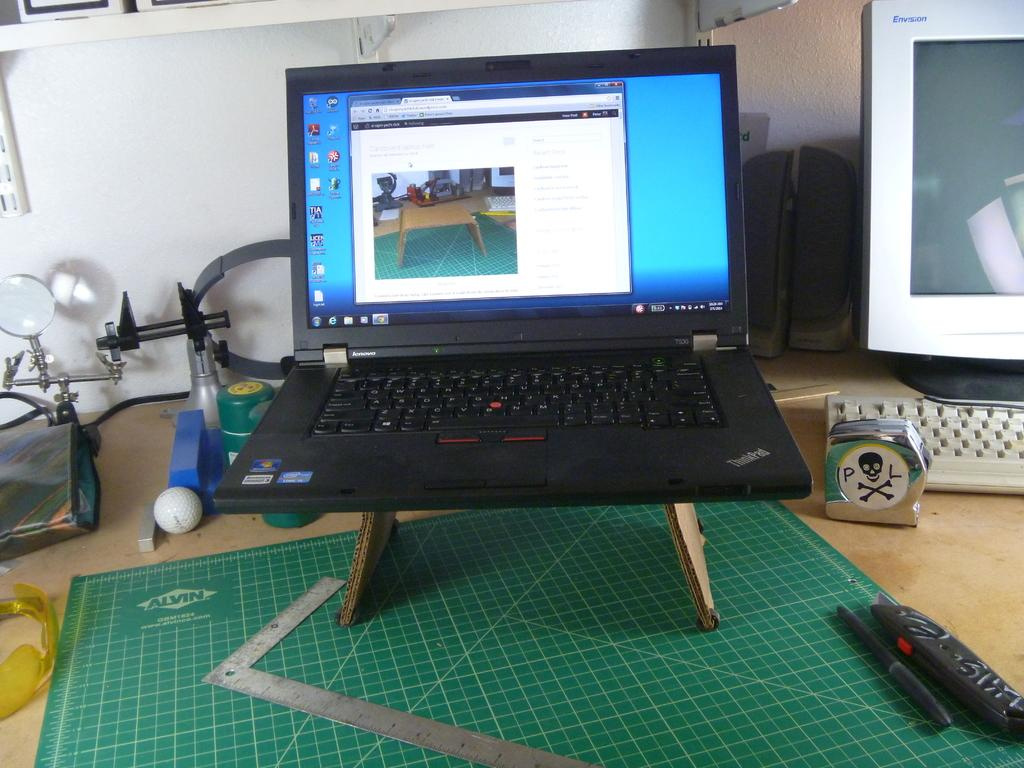<image>
Offer a succinct explanation of the picture presented. A windows laptop on a stand on top of a Alvin grid. 